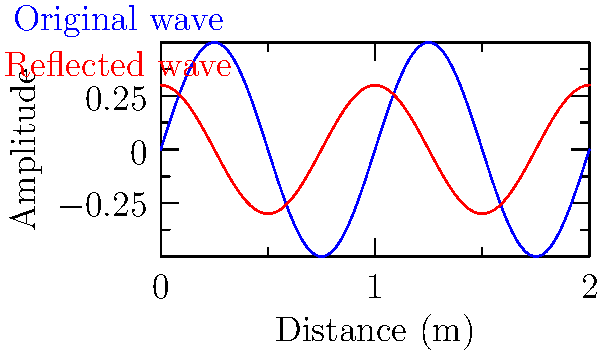For the art and wine exhibition, you want to ensure optimal acoustics for background music. The diagram shows an original sound wave (blue) and its reflection (red) in a room. If the room is 10 meters long and you want to create a standing wave for a frequency of 34 Hz, at what distance from the wall should you place the speaker? To solve this problem, we need to follow these steps:

1. Recall that the wavelength (λ) of a standing wave in a room is related to the room length (L) by the equation:
   $$L = n\frac{\lambda}{2}$$
   where n is an integer (1, 2, 3, ...)

2. For the fundamental frequency (n = 1), we have:
   $$L = \frac{\lambda}{2}$$

3. We know that the speed of sound (v) is related to frequency (f) and wavelength (λ) by:
   $$v = f\lambda$$

4. The speed of sound in air at room temperature is approximately 343 m/s.

5. Rearrange the equation to solve for λ:
   $$\lambda = \frac{v}{f} = \frac{343 \text{ m/s}}{34 \text{ Hz}} = 10.09 \text{ m}$$

6. To create a standing wave, the speaker should be placed at a distance of λ/4 from the wall. This is because the wall acts as a node (point of minimum amplitude), and we want the speaker to be at an antinode (point of maximum amplitude).

7. Calculate the speaker placement:
   $$\text{Speaker distance} = \frac{\lambda}{4} = \frac{10.09 \text{ m}}{4} = 2.52 \text{ m}$$

Therefore, the speaker should be placed 2.52 meters from the wall to create a standing wave for the given frequency in the 10-meter long room.
Answer: 2.52 meters 